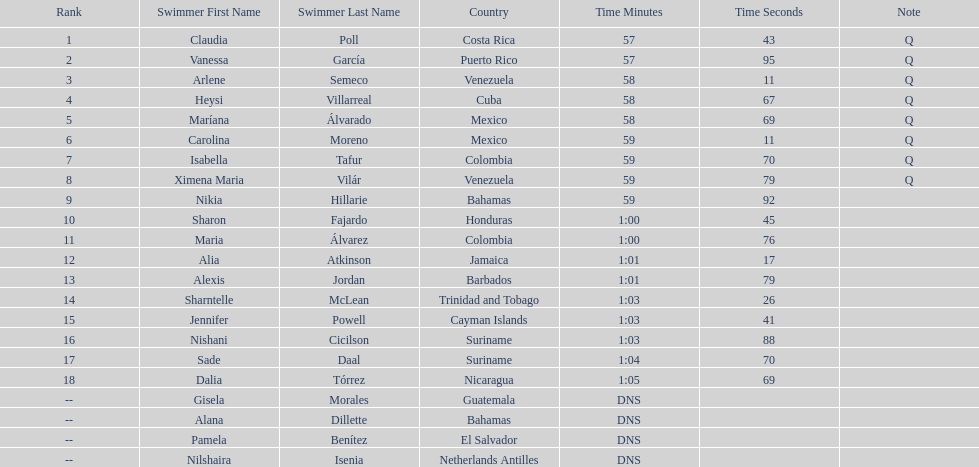How many mexican swimmers ranked in the top 10? 2. 